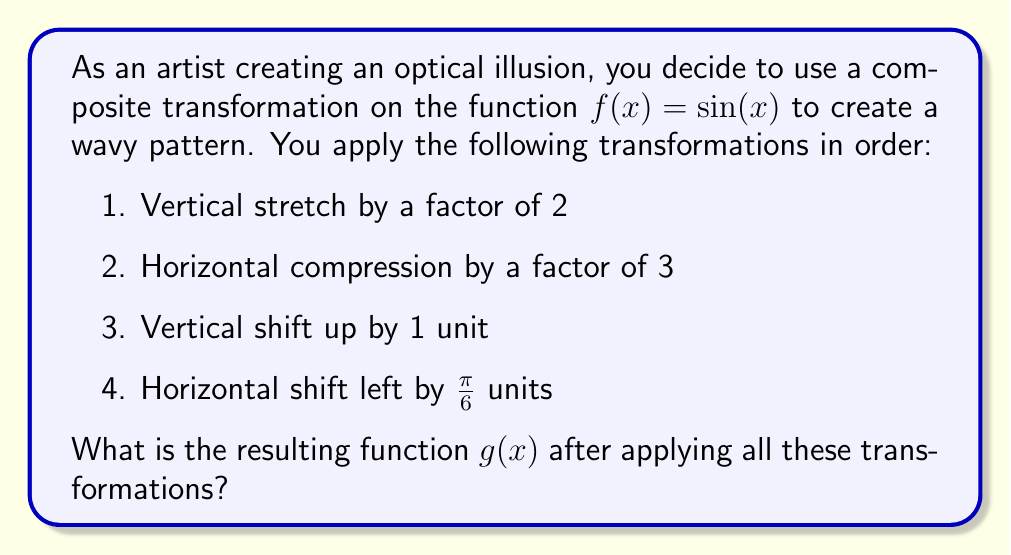Show me your answer to this math problem. Let's apply the transformations step by step:

1. Vertical stretch by a factor of 2:
   $f_1(x) = 2\sin(x)$

2. Horizontal compression by a factor of 3:
   $f_2(x) = 2\sin(3x)$

3. Vertical shift up by 1 unit:
   $f_3(x) = 2\sin(3x) + 1$

4. Horizontal shift left by $\frac{\pi}{6}$ units:
   To shift left, we add inside the function.
   $g(x) = 2\sin(3(x + \frac{\pi}{6})) + 1$

Simplifying the expression inside the sine function:
$g(x) = 2\sin(3x + \frac{\pi}{2}) + 1$

This is the final transformed function.
Answer: $g(x) = 2\sin(3x + \frac{\pi}{2}) + 1$ 